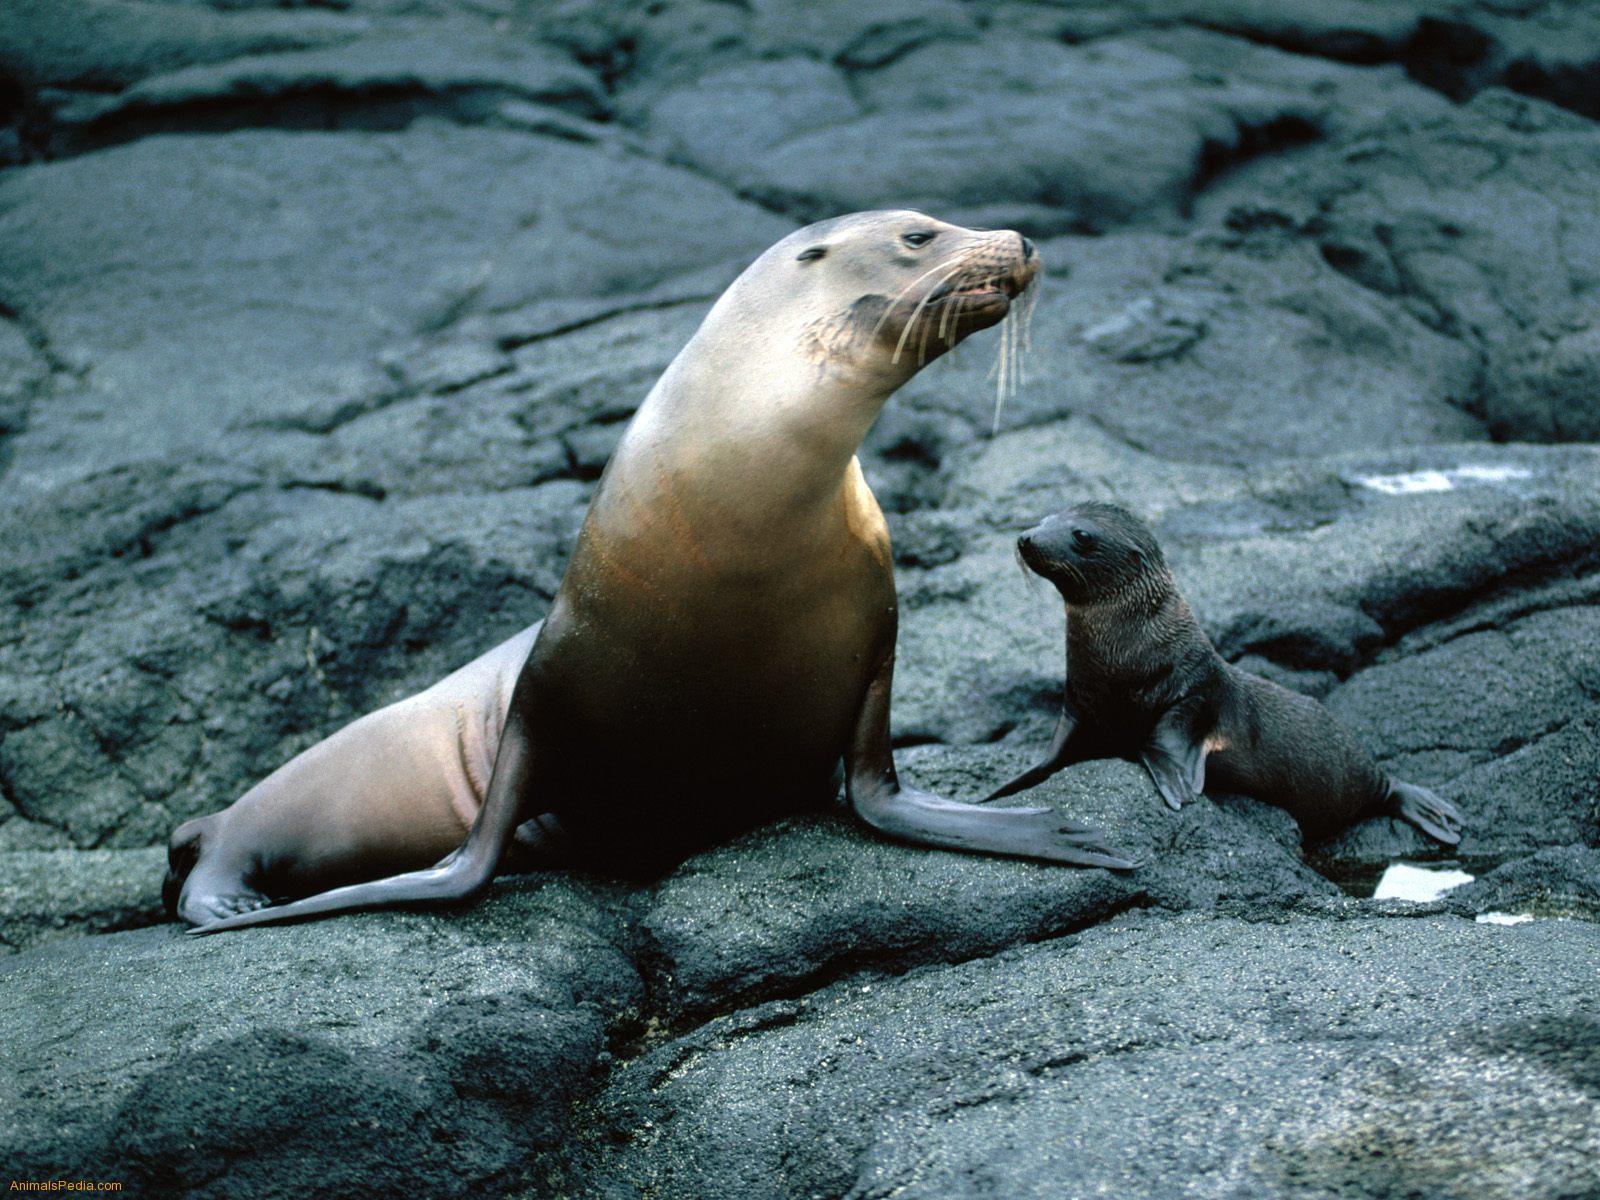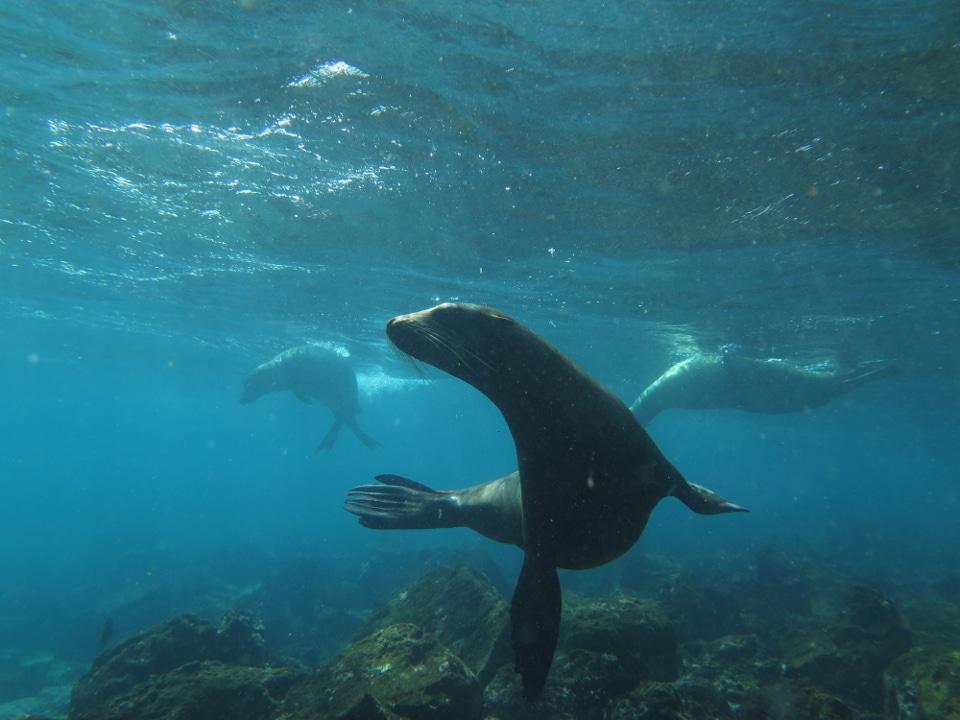The first image is the image on the left, the second image is the image on the right. Given the left and right images, does the statement "The left image contains exactly two seals." hold true? Answer yes or no. Yes. 